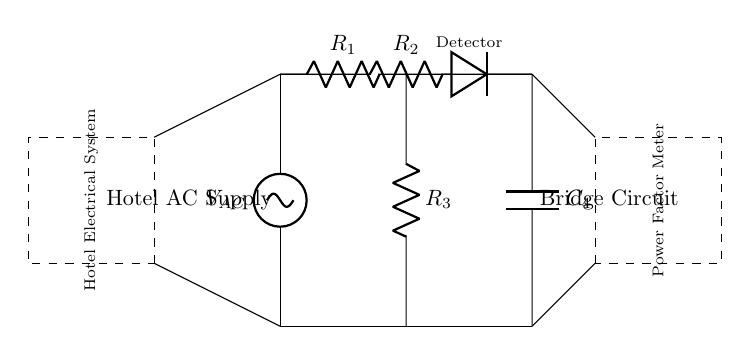What is the type of voltage source used in the circuit? The circuit uses an AC source, indicated by the symbol for the voltage supply labeled with an AC suffix.
Answer: AC What components are present in the left arm of the bridge? The left arm consists of two resistors: R1 and R3, as shown by their respective symbols in the circuit diagram.
Answer: R1, R3 What is the purpose of the detector in the circuit? The detector serves to compare the voltages across the bridge circuit and helps in measuring the balance of the circuit, useful for assessing power factor.
Answer: Measure power factor How many resistors are there in total in this circuit? The circuit contains three resistors: R1, R2, and R3, as labeled in the diagram, along with a capacitor.
Answer: Three What happens to the balance of the bridge if the power factor changes? A change in the power factor affects the current and voltage relationships, altering the balance of the bridge, which can show varying readings on the power factor meter.
Answer: Affects balance What is the relationship between the capacitors and the resistors in this AC bridge? The capacitors and resistors are used to create a certain phase angle between voltages, impacting the power factor measurement, which is key to determining the efficiency of the load.
Answer: Phase angle relationship Which component is responsible for measuring the power factor in this setup? The power factor meter, as indicated by the dashed rectangle labeled in the diagram, is responsible for taking the measurements.
Answer: Power factor meter 